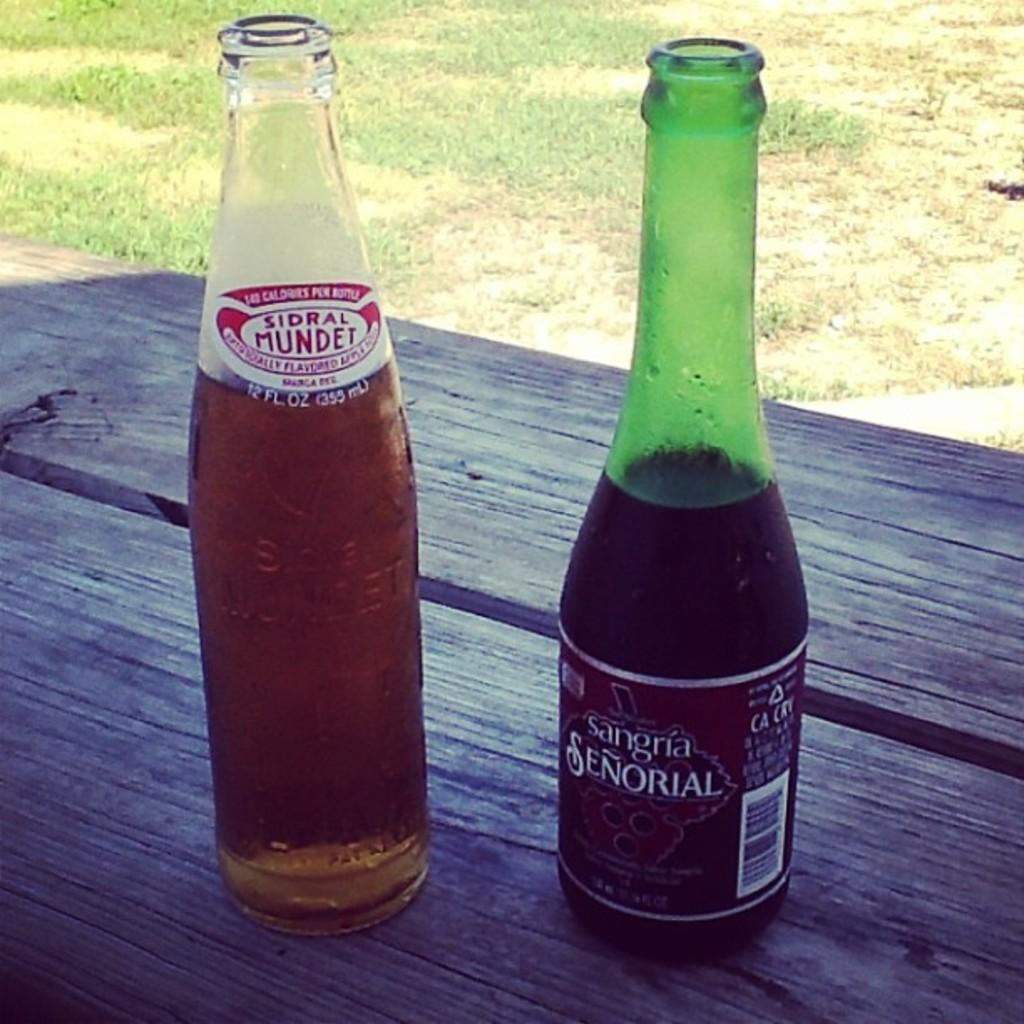<image>
Create a compact narrative representing the image presented. the word senorial is on the green beer 